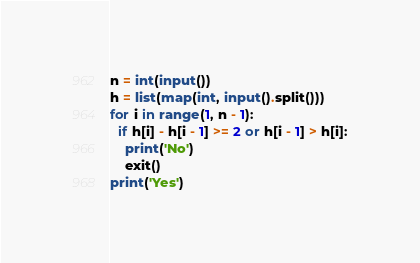<code> <loc_0><loc_0><loc_500><loc_500><_Python_>n = int(input())
h = list(map(int, input().split()))
for i in range(1, n - 1):
  if h[i] - h[i - 1] >= 2 or h[i - 1] > h[i]:
    print('No')
    exit()
print('Yes')</code> 